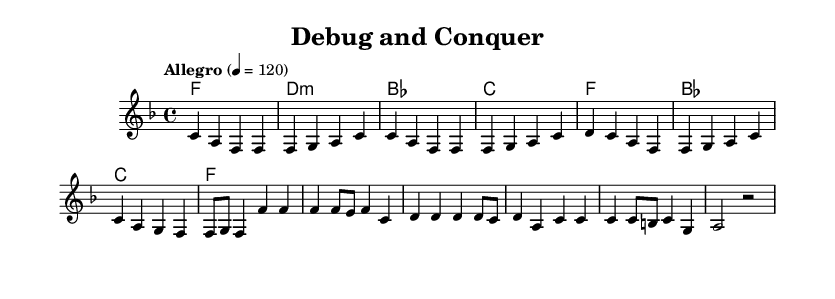What is the key signature of this music? The key signature is F major, which has one flat (B flat). This is determined by the key indicated in the global section of the code.
Answer: F major What is the time signature of this piece? The time signature is 4/4, as stated in the global section of the code, indicating four beats per measure with a quarter note getting one beat.
Answer: 4/4 What is the tempo marking for the song? The tempo marking is "Allegro" at a speed of 120 beats per minute, as noted in the global section of the code.
Answer: Allegro 4 = 120 How many measures are there in the verse? There are four measures in the verse, which can be counted by analyzing the melodic line in the `melody` section of the code where the verse is outlined.
Answer: 4 What is the last note in the chorus? The last note in the chorus is a half note (g). This can be identified by examining the last measure of the melody section corresponding to the chorus.
Answer: g What is the main theme conveyed in the lyrics? The main theme conveyed in the lyrics is problem-solving and resilience in the face of technical challenges, as detailed in both the verse and chorus words.
Answer: Problem-solving Which section features the lyrics "Debug and conquer, that's my way"? This phrase appears in the chorus section of the lyrics, which is set to music after the first verse and is clearly marked in the lyrical arrangement.
Answer: Chorus 